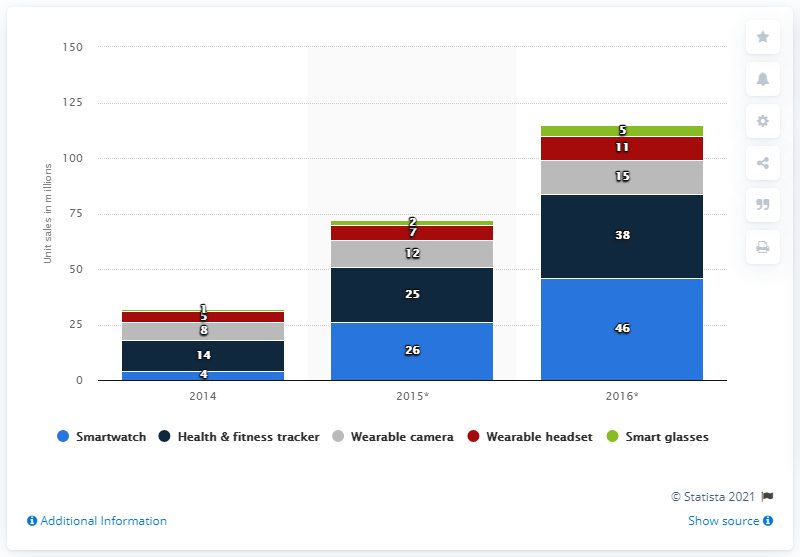List a handful of essential elements in this visual. In 2016, there were 11 wearable headsets. It is predicted that worldwide unit sales of health and fitness tracker wearables will reach approximately 25 million in 2015. In 2016, the total number of wearable headsets and wearable cameras was 26. 